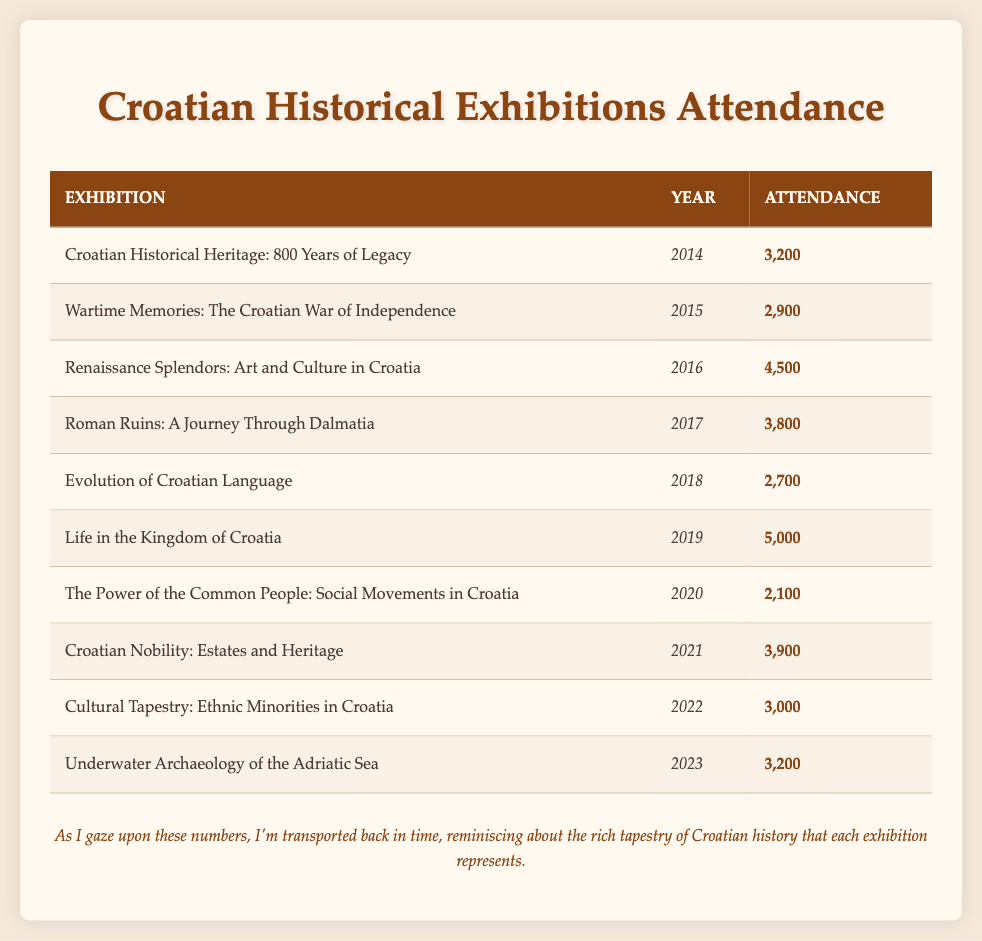What was the attendance in 2016? The table shows that the exhibition "Renaissance Splendors: Art and Culture in Croatia" had an attendance of 4500 in the year 2016.
Answer: 4500 Which exhibition had the lowest attendance? By examining the attendance figures, "The Power of the Common People: Social Movements in Croatia" had the lowest attendance with 2100.
Answer: 2100 What is the sum of attendances from 2014 to 2019? The attendances from 2014 to 2019 are as follows: 3200 (2014) + 2900 (2015) + 4500 (2016) + 3800 (2017) + 2700 (2018) + 5000 (2019). Adding these gives a total of 3200 + 2900 + 4500 + 3800 + 2700 + 5000 = 22100.
Answer: 22100 Did the attendance increase from 2022 to 2023? The attendance for "Cultural Tapestry: Ethnic Minorities in Croatia" in 2022 was 3000, and for "Underwater Archaeology of the Adriatic Sea" in 2023, it was 3200. Since 3200 is greater than 3000, the attendance did increase.
Answer: Yes What was the average attendance across all exhibitions listed? To find the average, add all attendances: 3200 + 2900 + 4500 + 3800 + 2700 + 5000 + 2100 + 3900 + 3000 + 3200 =  32500. There are 10 exhibitions. Divide the total attendance by the number of exhibitions: 32500 / 10 = 3250.
Answer: 3250 